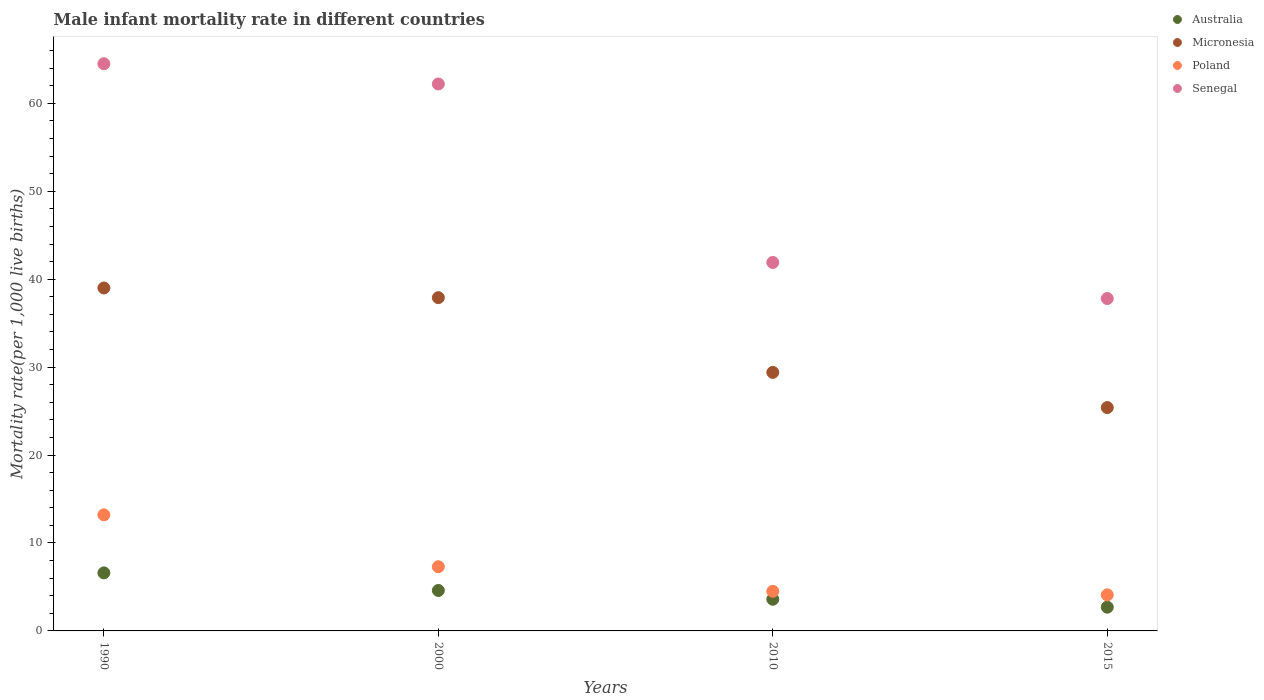Is the number of dotlines equal to the number of legend labels?
Your answer should be very brief. Yes. What is the male infant mortality rate in Senegal in 1990?
Keep it short and to the point. 64.5. Across all years, what is the maximum male infant mortality rate in Poland?
Your answer should be very brief. 13.2. Across all years, what is the minimum male infant mortality rate in Senegal?
Keep it short and to the point. 37.8. In which year was the male infant mortality rate in Australia maximum?
Keep it short and to the point. 1990. In which year was the male infant mortality rate in Micronesia minimum?
Provide a succinct answer. 2015. What is the total male infant mortality rate in Micronesia in the graph?
Your answer should be very brief. 131.7. What is the difference between the male infant mortality rate in Senegal in 1990 and that in 2010?
Keep it short and to the point. 22.6. What is the average male infant mortality rate in Senegal per year?
Offer a very short reply. 51.6. In the year 2015, what is the difference between the male infant mortality rate in Senegal and male infant mortality rate in Australia?
Give a very brief answer. 35.1. In how many years, is the male infant mortality rate in Poland greater than 32?
Offer a very short reply. 0. What is the ratio of the male infant mortality rate in Senegal in 1990 to that in 2010?
Provide a short and direct response. 1.54. Is the difference between the male infant mortality rate in Senegal in 2000 and 2015 greater than the difference between the male infant mortality rate in Australia in 2000 and 2015?
Provide a succinct answer. Yes. What is the difference between the highest and the second highest male infant mortality rate in Senegal?
Offer a very short reply. 2.3. What is the difference between the highest and the lowest male infant mortality rate in Micronesia?
Your answer should be compact. 13.6. Is the sum of the male infant mortality rate in Australia in 1990 and 2015 greater than the maximum male infant mortality rate in Micronesia across all years?
Your answer should be compact. No. Is it the case that in every year, the sum of the male infant mortality rate in Australia and male infant mortality rate in Senegal  is greater than the sum of male infant mortality rate in Poland and male infant mortality rate in Micronesia?
Your response must be concise. Yes. Is it the case that in every year, the sum of the male infant mortality rate in Poland and male infant mortality rate in Australia  is greater than the male infant mortality rate in Micronesia?
Provide a succinct answer. No. How many years are there in the graph?
Ensure brevity in your answer.  4. What is the difference between two consecutive major ticks on the Y-axis?
Make the answer very short. 10. Are the values on the major ticks of Y-axis written in scientific E-notation?
Ensure brevity in your answer.  No. Does the graph contain any zero values?
Provide a short and direct response. No. Does the graph contain grids?
Your answer should be compact. No. How many legend labels are there?
Your response must be concise. 4. How are the legend labels stacked?
Offer a terse response. Vertical. What is the title of the graph?
Offer a very short reply. Male infant mortality rate in different countries. What is the label or title of the Y-axis?
Provide a short and direct response. Mortality rate(per 1,0 live births). What is the Mortality rate(per 1,000 live births) of Australia in 1990?
Provide a succinct answer. 6.6. What is the Mortality rate(per 1,000 live births) of Poland in 1990?
Offer a very short reply. 13.2. What is the Mortality rate(per 1,000 live births) in Senegal in 1990?
Make the answer very short. 64.5. What is the Mortality rate(per 1,000 live births) of Micronesia in 2000?
Provide a succinct answer. 37.9. What is the Mortality rate(per 1,000 live births) in Senegal in 2000?
Your answer should be very brief. 62.2. What is the Mortality rate(per 1,000 live births) in Australia in 2010?
Make the answer very short. 3.6. What is the Mortality rate(per 1,000 live births) of Micronesia in 2010?
Your answer should be compact. 29.4. What is the Mortality rate(per 1,000 live births) of Senegal in 2010?
Ensure brevity in your answer.  41.9. What is the Mortality rate(per 1,000 live births) of Micronesia in 2015?
Give a very brief answer. 25.4. What is the Mortality rate(per 1,000 live births) in Senegal in 2015?
Your answer should be compact. 37.8. Across all years, what is the maximum Mortality rate(per 1,000 live births) in Micronesia?
Keep it short and to the point. 39. Across all years, what is the maximum Mortality rate(per 1,000 live births) in Senegal?
Give a very brief answer. 64.5. Across all years, what is the minimum Mortality rate(per 1,000 live births) of Australia?
Make the answer very short. 2.7. Across all years, what is the minimum Mortality rate(per 1,000 live births) of Micronesia?
Your answer should be very brief. 25.4. Across all years, what is the minimum Mortality rate(per 1,000 live births) in Poland?
Offer a very short reply. 4.1. Across all years, what is the minimum Mortality rate(per 1,000 live births) in Senegal?
Your response must be concise. 37.8. What is the total Mortality rate(per 1,000 live births) in Micronesia in the graph?
Keep it short and to the point. 131.7. What is the total Mortality rate(per 1,000 live births) in Poland in the graph?
Offer a terse response. 29.1. What is the total Mortality rate(per 1,000 live births) in Senegal in the graph?
Provide a short and direct response. 206.4. What is the difference between the Mortality rate(per 1,000 live births) in Poland in 1990 and that in 2000?
Give a very brief answer. 5.9. What is the difference between the Mortality rate(per 1,000 live births) in Senegal in 1990 and that in 2000?
Offer a terse response. 2.3. What is the difference between the Mortality rate(per 1,000 live births) in Australia in 1990 and that in 2010?
Provide a short and direct response. 3. What is the difference between the Mortality rate(per 1,000 live births) of Poland in 1990 and that in 2010?
Provide a succinct answer. 8.7. What is the difference between the Mortality rate(per 1,000 live births) in Senegal in 1990 and that in 2010?
Your answer should be very brief. 22.6. What is the difference between the Mortality rate(per 1,000 live births) of Australia in 1990 and that in 2015?
Make the answer very short. 3.9. What is the difference between the Mortality rate(per 1,000 live births) in Poland in 1990 and that in 2015?
Keep it short and to the point. 9.1. What is the difference between the Mortality rate(per 1,000 live births) of Senegal in 1990 and that in 2015?
Provide a succinct answer. 26.7. What is the difference between the Mortality rate(per 1,000 live births) of Micronesia in 2000 and that in 2010?
Offer a terse response. 8.5. What is the difference between the Mortality rate(per 1,000 live births) of Poland in 2000 and that in 2010?
Keep it short and to the point. 2.8. What is the difference between the Mortality rate(per 1,000 live births) of Senegal in 2000 and that in 2010?
Provide a succinct answer. 20.3. What is the difference between the Mortality rate(per 1,000 live births) in Micronesia in 2000 and that in 2015?
Your response must be concise. 12.5. What is the difference between the Mortality rate(per 1,000 live births) in Senegal in 2000 and that in 2015?
Offer a very short reply. 24.4. What is the difference between the Mortality rate(per 1,000 live births) of Senegal in 2010 and that in 2015?
Make the answer very short. 4.1. What is the difference between the Mortality rate(per 1,000 live births) of Australia in 1990 and the Mortality rate(per 1,000 live births) of Micronesia in 2000?
Offer a terse response. -31.3. What is the difference between the Mortality rate(per 1,000 live births) of Australia in 1990 and the Mortality rate(per 1,000 live births) of Senegal in 2000?
Your response must be concise. -55.6. What is the difference between the Mortality rate(per 1,000 live births) of Micronesia in 1990 and the Mortality rate(per 1,000 live births) of Poland in 2000?
Your answer should be compact. 31.7. What is the difference between the Mortality rate(per 1,000 live births) in Micronesia in 1990 and the Mortality rate(per 1,000 live births) in Senegal in 2000?
Keep it short and to the point. -23.2. What is the difference between the Mortality rate(per 1,000 live births) in Poland in 1990 and the Mortality rate(per 1,000 live births) in Senegal in 2000?
Provide a succinct answer. -49. What is the difference between the Mortality rate(per 1,000 live births) of Australia in 1990 and the Mortality rate(per 1,000 live births) of Micronesia in 2010?
Ensure brevity in your answer.  -22.8. What is the difference between the Mortality rate(per 1,000 live births) in Australia in 1990 and the Mortality rate(per 1,000 live births) in Senegal in 2010?
Your response must be concise. -35.3. What is the difference between the Mortality rate(per 1,000 live births) in Micronesia in 1990 and the Mortality rate(per 1,000 live births) in Poland in 2010?
Your response must be concise. 34.5. What is the difference between the Mortality rate(per 1,000 live births) of Micronesia in 1990 and the Mortality rate(per 1,000 live births) of Senegal in 2010?
Keep it short and to the point. -2.9. What is the difference between the Mortality rate(per 1,000 live births) of Poland in 1990 and the Mortality rate(per 1,000 live births) of Senegal in 2010?
Keep it short and to the point. -28.7. What is the difference between the Mortality rate(per 1,000 live births) of Australia in 1990 and the Mortality rate(per 1,000 live births) of Micronesia in 2015?
Make the answer very short. -18.8. What is the difference between the Mortality rate(per 1,000 live births) of Australia in 1990 and the Mortality rate(per 1,000 live births) of Poland in 2015?
Your response must be concise. 2.5. What is the difference between the Mortality rate(per 1,000 live births) in Australia in 1990 and the Mortality rate(per 1,000 live births) in Senegal in 2015?
Offer a very short reply. -31.2. What is the difference between the Mortality rate(per 1,000 live births) of Micronesia in 1990 and the Mortality rate(per 1,000 live births) of Poland in 2015?
Provide a short and direct response. 34.9. What is the difference between the Mortality rate(per 1,000 live births) of Micronesia in 1990 and the Mortality rate(per 1,000 live births) of Senegal in 2015?
Your answer should be compact. 1.2. What is the difference between the Mortality rate(per 1,000 live births) in Poland in 1990 and the Mortality rate(per 1,000 live births) in Senegal in 2015?
Make the answer very short. -24.6. What is the difference between the Mortality rate(per 1,000 live births) in Australia in 2000 and the Mortality rate(per 1,000 live births) in Micronesia in 2010?
Provide a short and direct response. -24.8. What is the difference between the Mortality rate(per 1,000 live births) in Australia in 2000 and the Mortality rate(per 1,000 live births) in Senegal in 2010?
Your answer should be very brief. -37.3. What is the difference between the Mortality rate(per 1,000 live births) of Micronesia in 2000 and the Mortality rate(per 1,000 live births) of Poland in 2010?
Your response must be concise. 33.4. What is the difference between the Mortality rate(per 1,000 live births) in Poland in 2000 and the Mortality rate(per 1,000 live births) in Senegal in 2010?
Provide a succinct answer. -34.6. What is the difference between the Mortality rate(per 1,000 live births) in Australia in 2000 and the Mortality rate(per 1,000 live births) in Micronesia in 2015?
Your answer should be compact. -20.8. What is the difference between the Mortality rate(per 1,000 live births) of Australia in 2000 and the Mortality rate(per 1,000 live births) of Poland in 2015?
Keep it short and to the point. 0.5. What is the difference between the Mortality rate(per 1,000 live births) in Australia in 2000 and the Mortality rate(per 1,000 live births) in Senegal in 2015?
Keep it short and to the point. -33.2. What is the difference between the Mortality rate(per 1,000 live births) of Micronesia in 2000 and the Mortality rate(per 1,000 live births) of Poland in 2015?
Provide a succinct answer. 33.8. What is the difference between the Mortality rate(per 1,000 live births) in Micronesia in 2000 and the Mortality rate(per 1,000 live births) in Senegal in 2015?
Provide a succinct answer. 0.1. What is the difference between the Mortality rate(per 1,000 live births) in Poland in 2000 and the Mortality rate(per 1,000 live births) in Senegal in 2015?
Your answer should be very brief. -30.5. What is the difference between the Mortality rate(per 1,000 live births) of Australia in 2010 and the Mortality rate(per 1,000 live births) of Micronesia in 2015?
Provide a short and direct response. -21.8. What is the difference between the Mortality rate(per 1,000 live births) in Australia in 2010 and the Mortality rate(per 1,000 live births) in Senegal in 2015?
Your response must be concise. -34.2. What is the difference between the Mortality rate(per 1,000 live births) in Micronesia in 2010 and the Mortality rate(per 1,000 live births) in Poland in 2015?
Your response must be concise. 25.3. What is the difference between the Mortality rate(per 1,000 live births) of Micronesia in 2010 and the Mortality rate(per 1,000 live births) of Senegal in 2015?
Keep it short and to the point. -8.4. What is the difference between the Mortality rate(per 1,000 live births) in Poland in 2010 and the Mortality rate(per 1,000 live births) in Senegal in 2015?
Give a very brief answer. -33.3. What is the average Mortality rate(per 1,000 live births) in Australia per year?
Your response must be concise. 4.38. What is the average Mortality rate(per 1,000 live births) of Micronesia per year?
Your answer should be very brief. 32.92. What is the average Mortality rate(per 1,000 live births) in Poland per year?
Offer a terse response. 7.28. What is the average Mortality rate(per 1,000 live births) of Senegal per year?
Offer a terse response. 51.6. In the year 1990, what is the difference between the Mortality rate(per 1,000 live births) of Australia and Mortality rate(per 1,000 live births) of Micronesia?
Provide a short and direct response. -32.4. In the year 1990, what is the difference between the Mortality rate(per 1,000 live births) in Australia and Mortality rate(per 1,000 live births) in Senegal?
Give a very brief answer. -57.9. In the year 1990, what is the difference between the Mortality rate(per 1,000 live births) of Micronesia and Mortality rate(per 1,000 live births) of Poland?
Your response must be concise. 25.8. In the year 1990, what is the difference between the Mortality rate(per 1,000 live births) in Micronesia and Mortality rate(per 1,000 live births) in Senegal?
Your answer should be very brief. -25.5. In the year 1990, what is the difference between the Mortality rate(per 1,000 live births) of Poland and Mortality rate(per 1,000 live births) of Senegal?
Give a very brief answer. -51.3. In the year 2000, what is the difference between the Mortality rate(per 1,000 live births) in Australia and Mortality rate(per 1,000 live births) in Micronesia?
Provide a short and direct response. -33.3. In the year 2000, what is the difference between the Mortality rate(per 1,000 live births) in Australia and Mortality rate(per 1,000 live births) in Poland?
Your answer should be very brief. -2.7. In the year 2000, what is the difference between the Mortality rate(per 1,000 live births) of Australia and Mortality rate(per 1,000 live births) of Senegal?
Keep it short and to the point. -57.6. In the year 2000, what is the difference between the Mortality rate(per 1,000 live births) in Micronesia and Mortality rate(per 1,000 live births) in Poland?
Provide a short and direct response. 30.6. In the year 2000, what is the difference between the Mortality rate(per 1,000 live births) in Micronesia and Mortality rate(per 1,000 live births) in Senegal?
Provide a short and direct response. -24.3. In the year 2000, what is the difference between the Mortality rate(per 1,000 live births) of Poland and Mortality rate(per 1,000 live births) of Senegal?
Your response must be concise. -54.9. In the year 2010, what is the difference between the Mortality rate(per 1,000 live births) of Australia and Mortality rate(per 1,000 live births) of Micronesia?
Give a very brief answer. -25.8. In the year 2010, what is the difference between the Mortality rate(per 1,000 live births) in Australia and Mortality rate(per 1,000 live births) in Senegal?
Offer a terse response. -38.3. In the year 2010, what is the difference between the Mortality rate(per 1,000 live births) in Micronesia and Mortality rate(per 1,000 live births) in Poland?
Your response must be concise. 24.9. In the year 2010, what is the difference between the Mortality rate(per 1,000 live births) in Poland and Mortality rate(per 1,000 live births) in Senegal?
Offer a very short reply. -37.4. In the year 2015, what is the difference between the Mortality rate(per 1,000 live births) in Australia and Mortality rate(per 1,000 live births) in Micronesia?
Offer a very short reply. -22.7. In the year 2015, what is the difference between the Mortality rate(per 1,000 live births) in Australia and Mortality rate(per 1,000 live births) in Senegal?
Offer a very short reply. -35.1. In the year 2015, what is the difference between the Mortality rate(per 1,000 live births) of Micronesia and Mortality rate(per 1,000 live births) of Poland?
Ensure brevity in your answer.  21.3. In the year 2015, what is the difference between the Mortality rate(per 1,000 live births) of Poland and Mortality rate(per 1,000 live births) of Senegal?
Offer a terse response. -33.7. What is the ratio of the Mortality rate(per 1,000 live births) in Australia in 1990 to that in 2000?
Your response must be concise. 1.43. What is the ratio of the Mortality rate(per 1,000 live births) in Poland in 1990 to that in 2000?
Offer a very short reply. 1.81. What is the ratio of the Mortality rate(per 1,000 live births) in Senegal in 1990 to that in 2000?
Your response must be concise. 1.04. What is the ratio of the Mortality rate(per 1,000 live births) in Australia in 1990 to that in 2010?
Keep it short and to the point. 1.83. What is the ratio of the Mortality rate(per 1,000 live births) of Micronesia in 1990 to that in 2010?
Keep it short and to the point. 1.33. What is the ratio of the Mortality rate(per 1,000 live births) in Poland in 1990 to that in 2010?
Provide a succinct answer. 2.93. What is the ratio of the Mortality rate(per 1,000 live births) of Senegal in 1990 to that in 2010?
Provide a short and direct response. 1.54. What is the ratio of the Mortality rate(per 1,000 live births) of Australia in 1990 to that in 2015?
Your answer should be very brief. 2.44. What is the ratio of the Mortality rate(per 1,000 live births) of Micronesia in 1990 to that in 2015?
Offer a very short reply. 1.54. What is the ratio of the Mortality rate(per 1,000 live births) of Poland in 1990 to that in 2015?
Provide a short and direct response. 3.22. What is the ratio of the Mortality rate(per 1,000 live births) in Senegal in 1990 to that in 2015?
Your answer should be very brief. 1.71. What is the ratio of the Mortality rate(per 1,000 live births) in Australia in 2000 to that in 2010?
Give a very brief answer. 1.28. What is the ratio of the Mortality rate(per 1,000 live births) in Micronesia in 2000 to that in 2010?
Make the answer very short. 1.29. What is the ratio of the Mortality rate(per 1,000 live births) of Poland in 2000 to that in 2010?
Make the answer very short. 1.62. What is the ratio of the Mortality rate(per 1,000 live births) of Senegal in 2000 to that in 2010?
Offer a terse response. 1.48. What is the ratio of the Mortality rate(per 1,000 live births) in Australia in 2000 to that in 2015?
Offer a very short reply. 1.7. What is the ratio of the Mortality rate(per 1,000 live births) in Micronesia in 2000 to that in 2015?
Provide a short and direct response. 1.49. What is the ratio of the Mortality rate(per 1,000 live births) in Poland in 2000 to that in 2015?
Your answer should be compact. 1.78. What is the ratio of the Mortality rate(per 1,000 live births) in Senegal in 2000 to that in 2015?
Keep it short and to the point. 1.65. What is the ratio of the Mortality rate(per 1,000 live births) of Micronesia in 2010 to that in 2015?
Your answer should be very brief. 1.16. What is the ratio of the Mortality rate(per 1,000 live births) in Poland in 2010 to that in 2015?
Provide a short and direct response. 1.1. What is the ratio of the Mortality rate(per 1,000 live births) of Senegal in 2010 to that in 2015?
Offer a terse response. 1.11. What is the difference between the highest and the second highest Mortality rate(per 1,000 live births) in Australia?
Your answer should be compact. 2. What is the difference between the highest and the lowest Mortality rate(per 1,000 live births) in Micronesia?
Provide a succinct answer. 13.6. What is the difference between the highest and the lowest Mortality rate(per 1,000 live births) in Poland?
Ensure brevity in your answer.  9.1. What is the difference between the highest and the lowest Mortality rate(per 1,000 live births) in Senegal?
Make the answer very short. 26.7. 